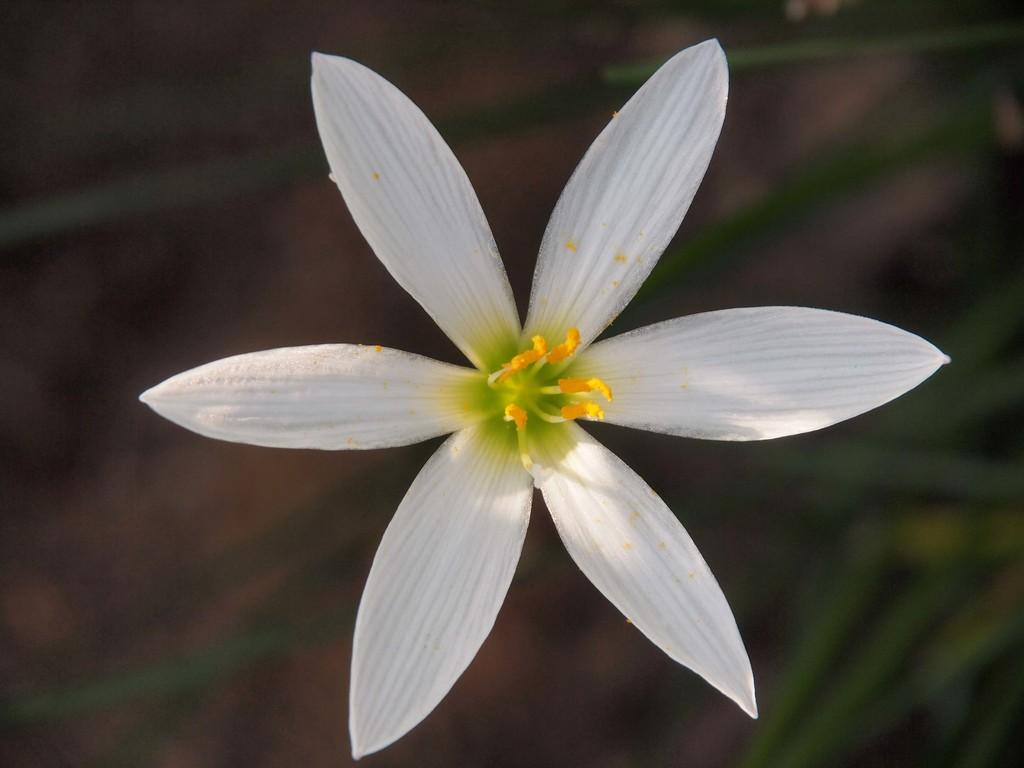What type of flower is in the image? There is a flower with white petals in the image. What can be found on the flower? The flower has pollen grains. Can you describe the background of the image? The background of the image appears blurry. How many dolls are playing with a ball in the field in the image? There are no dolls, balls, or fields present in the image; it features a flower with white petals and a blurry background. 